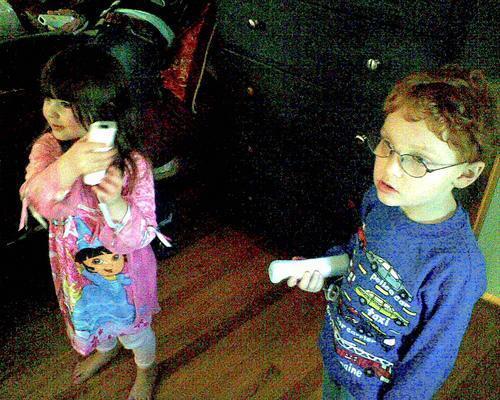How many people are in the picture?
Give a very brief answer. 2. How many talons does the bird have?
Give a very brief answer. 0. 